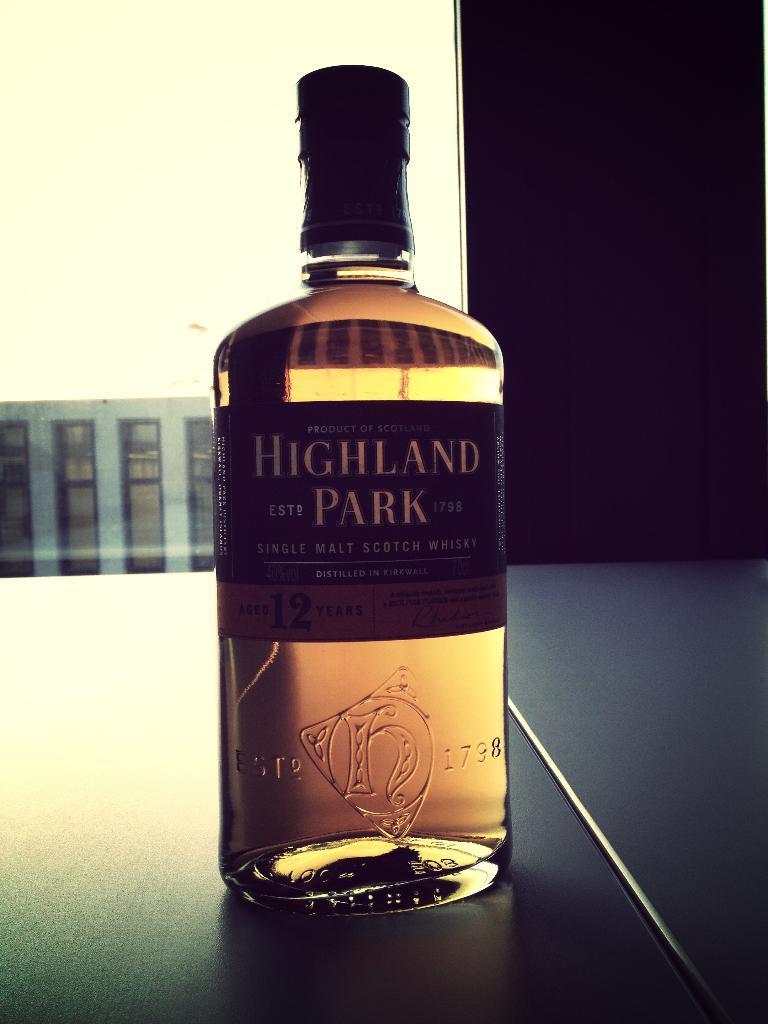Could you give a brief overview of what you see in this image? In this picture we can see a bottle. 